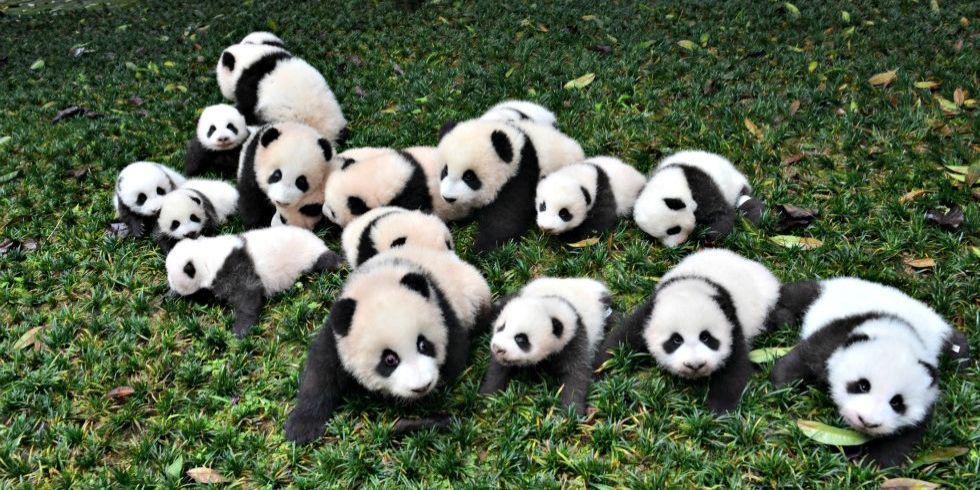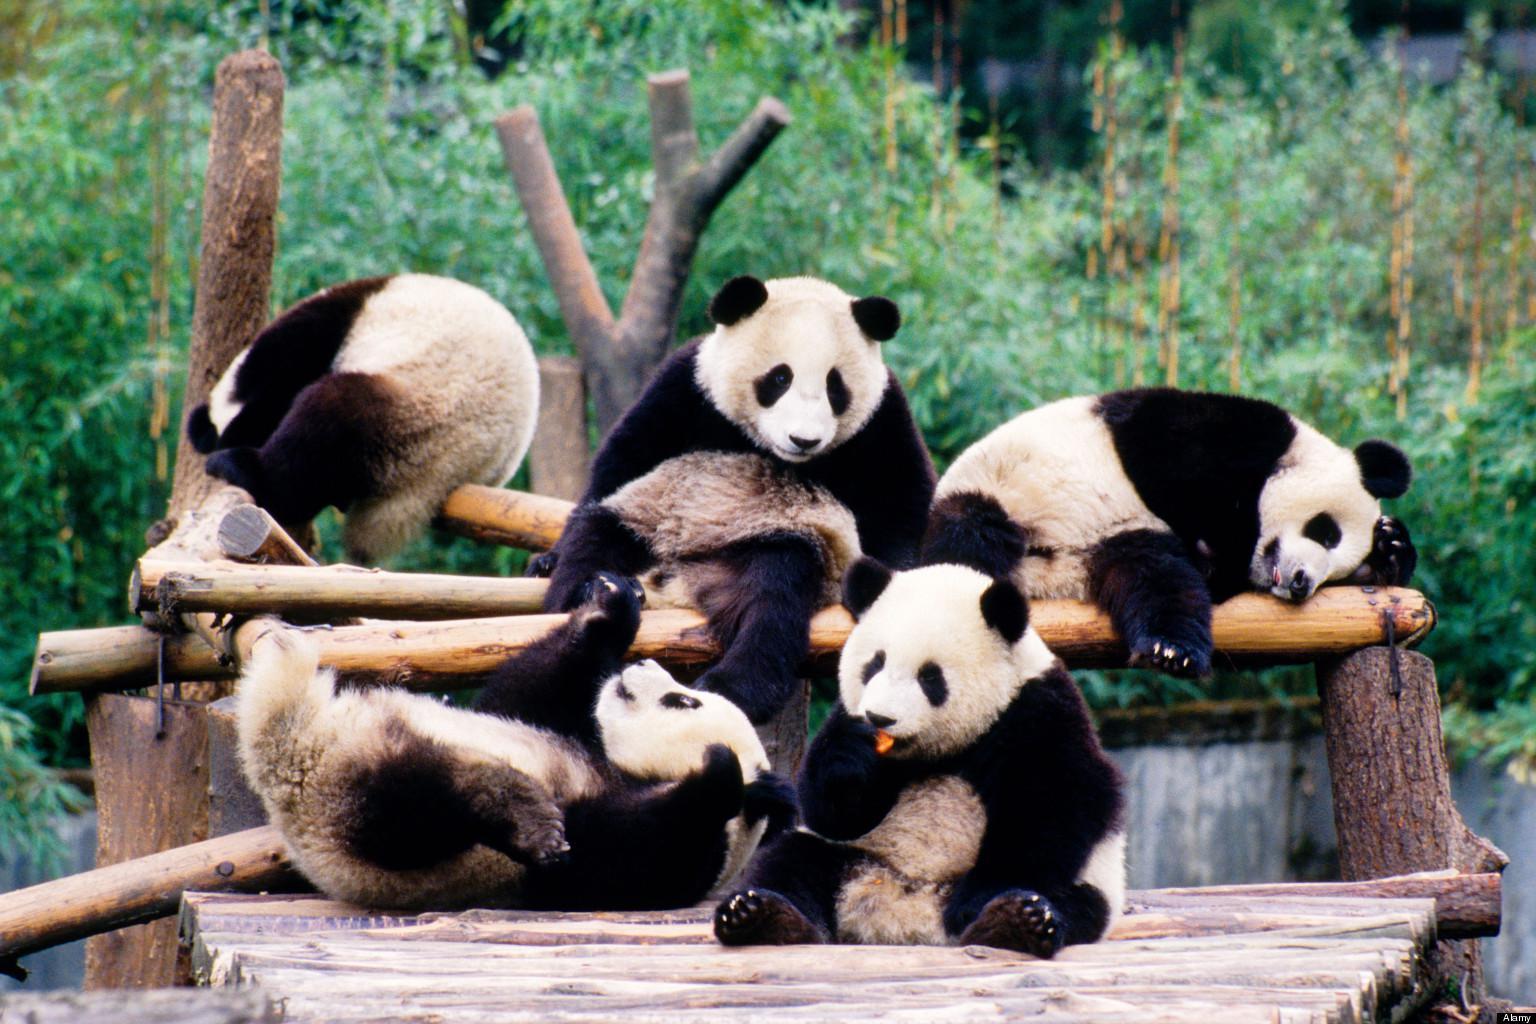The first image is the image on the left, the second image is the image on the right. For the images shown, is this caption "There are at most three pandas in one of the images." true? Answer yes or no. No. The first image is the image on the left, the second image is the image on the right. Evaluate the accuracy of this statement regarding the images: "There is a single panda in one of the images.". Is it true? Answer yes or no. No. 